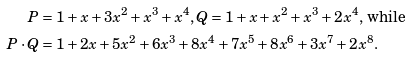<formula> <loc_0><loc_0><loc_500><loc_500>P & = 1 + x + 3 x ^ { 2 } + x ^ { 3 } + x ^ { 4 } , Q = 1 + x + x ^ { 2 } + x ^ { 3 } + 2 x ^ { 4 } \text {, while} \\ P \cdot Q & = 1 + 2 x + 5 x ^ { 2 } + 6 x ^ { 3 } + 8 x ^ { 4 } + 7 x ^ { 5 } + 8 x ^ { 6 } + 3 x ^ { 7 } + 2 x ^ { 8 } .</formula> 